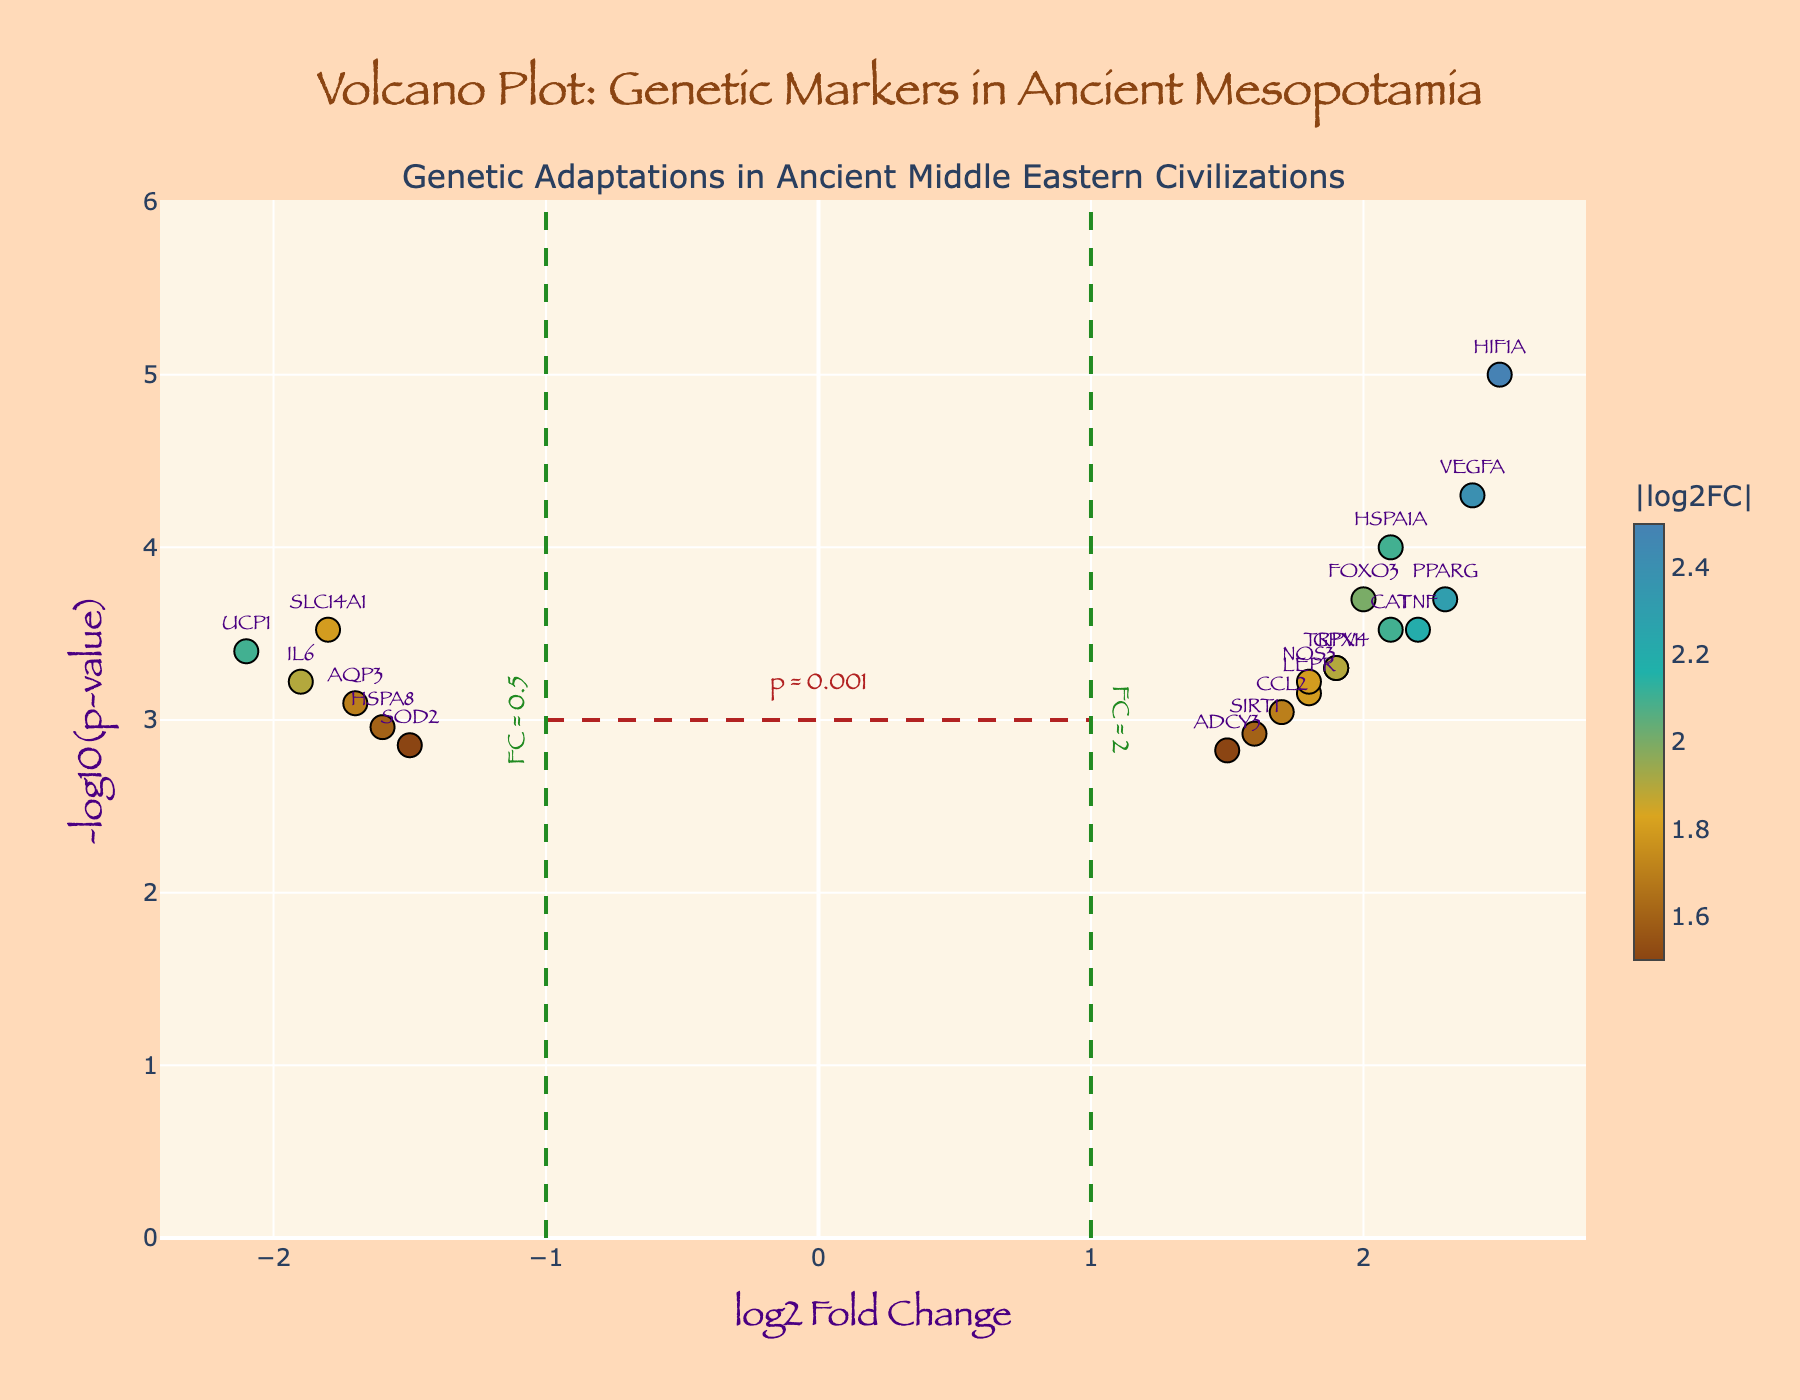What is the title of the plot? The title is usually placed at the top part of the plot. Here, it reads 'Volcano Plot: Genetic Markers in Ancient Mesopotamia'.
Answer: Volcano Plot: Genetic Markers in Ancient Mesopotamia What are the x-axis and y-axis titles in the plot? The x-axis title is 'log2 Fold Change' and the y-axis title is '-log10(p-value)' as described in the layout settings of the plot.
Answer: log2 Fold Change and -log10(p-value) How many data points are represented in the volcano plot? Count the number of markers or refer to the number of entries in the data list. There are 19 data points.
Answer: 19 Which gene has the highest log2 fold change value? Look for the data point with the highest x-axis value. HIF1A has a log2 fold change value of 2.5, the highest of all.
Answer: HIF1A Which gene has the lowest p-value? Check the y-axis for the highest value of -log10(pvalue). HIF1A has the lowest p-value, confirmed by its highest position on the y-axis.
Answer: HIF1A How many genes have a log2 fold change greater than 2? Observe the data points to the right of the 'FC = 2' line at x=1. Visual inspection or counting confirms there are 4 genes: PPARG, HIF1A, TNF, VEGFA.
Answer: 4 Which gene combines a high absolute log2 fold change and a very low p-value? Both high absolute log2FC and low p-values are represented by markers farthest from the center and located highest on the y-axis. HIF1A appears to meet these criteria.
Answer: HIF1A How many genes have a negative log2 fold change and are statistically significant (p < 0.001)? Statistical significance is indicated by markers above y=3, and a negative log2 fold change is indicated by points left of x=0. Count markers satisfying both conditions: SLC14A1, UCP1, and IL6, making 3 genes.
Answer: 3 What purpose do the dashed lines in the plot serve? The horizontal dashed line at y=3 represents a p-value threshold of 0.001, while the vertical dashed lines at x=-1 and x=1 indicate fold change thresholds of 0.5 and 2. These thresholds help visually identify significant markers.
Answer: They signify p-value and fold change thresholds 